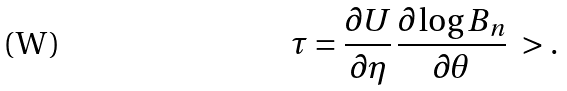Convert formula to latex. <formula><loc_0><loc_0><loc_500><loc_500>\tau = \frac { \partial U } { \partial \eta } \, \frac { \partial \log B _ { n } } { \partial \theta } \ > .</formula> 